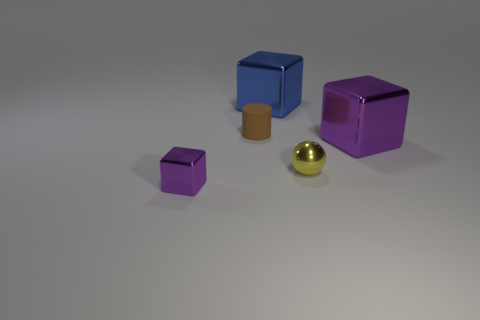Subtract all large purple cubes. How many cubes are left? 2 Subtract all purple cubes. How many cubes are left? 1 Add 3 big blue cubes. How many objects exist? 8 Subtract all cubes. How many objects are left? 2 Subtract all brown spheres. How many purple blocks are left? 2 Subtract 1 spheres. How many spheres are left? 0 Add 5 small brown objects. How many small brown objects exist? 6 Subtract 0 gray balls. How many objects are left? 5 Subtract all green blocks. Subtract all purple spheres. How many blocks are left? 3 Subtract all large green shiny things. Subtract all large things. How many objects are left? 3 